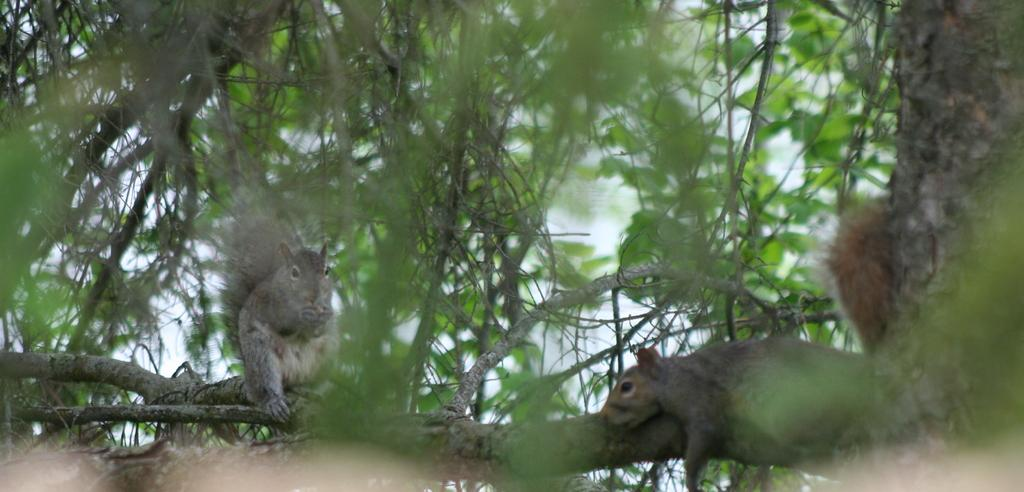What animals are on the wooden branch in the image? There are squirrels on the wooden branch in the image. What type of structure is the wooden branch part of? The wooden branch is part of a tree. What type of bone can be seen in the image? There is no bone present in the image; it features squirrels on a wooden branch. How many times does the squirrel drop from the branch in the image? There is no indication in the image that the squirrel drops from the branch, so it cannot be determined from the picture. 